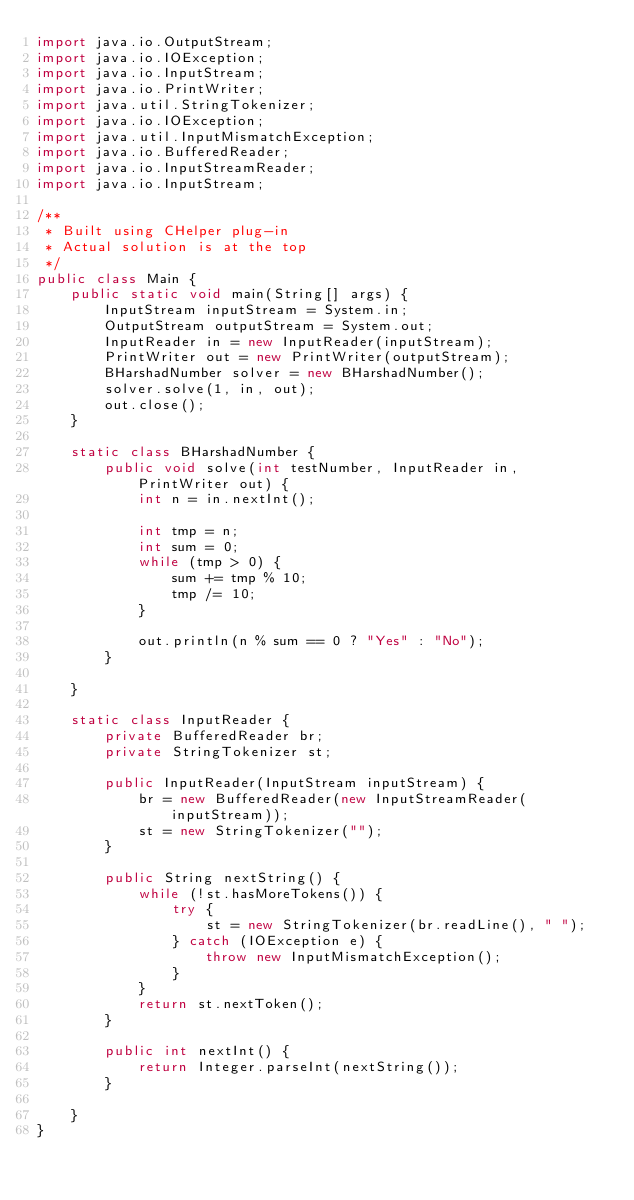<code> <loc_0><loc_0><loc_500><loc_500><_Java_>import java.io.OutputStream;
import java.io.IOException;
import java.io.InputStream;
import java.io.PrintWriter;
import java.util.StringTokenizer;
import java.io.IOException;
import java.util.InputMismatchException;
import java.io.BufferedReader;
import java.io.InputStreamReader;
import java.io.InputStream;

/**
 * Built using CHelper plug-in
 * Actual solution is at the top
 */
public class Main {
    public static void main(String[] args) {
        InputStream inputStream = System.in;
        OutputStream outputStream = System.out;
        InputReader in = new InputReader(inputStream);
        PrintWriter out = new PrintWriter(outputStream);
        BHarshadNumber solver = new BHarshadNumber();
        solver.solve(1, in, out);
        out.close();
    }

    static class BHarshadNumber {
        public void solve(int testNumber, InputReader in, PrintWriter out) {
            int n = in.nextInt();

            int tmp = n;
            int sum = 0;
            while (tmp > 0) {
                sum += tmp % 10;
                tmp /= 10;
            }

            out.println(n % sum == 0 ? "Yes" : "No");
        }

    }

    static class InputReader {
        private BufferedReader br;
        private StringTokenizer st;

        public InputReader(InputStream inputStream) {
            br = new BufferedReader(new InputStreamReader(inputStream));
            st = new StringTokenizer("");
        }

        public String nextString() {
            while (!st.hasMoreTokens()) {
                try {
                    st = new StringTokenizer(br.readLine(), " ");
                } catch (IOException e) {
                    throw new InputMismatchException();
                }
            }
            return st.nextToken();
        }

        public int nextInt() {
            return Integer.parseInt(nextString());
        }

    }
}

</code> 